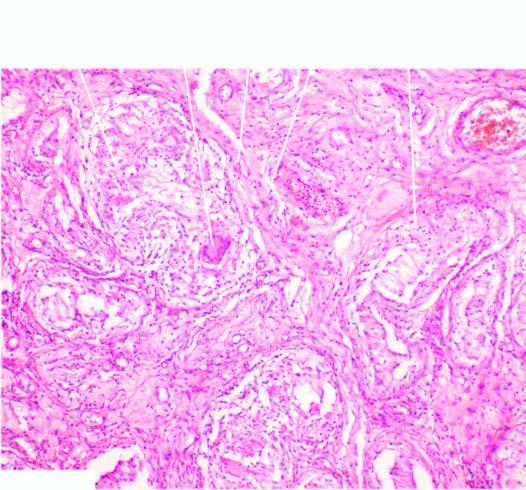how does the interstitium contain several epithelioid cell granulomas?
Answer the question using a single word or phrase. With central areas of caseation necrosis 